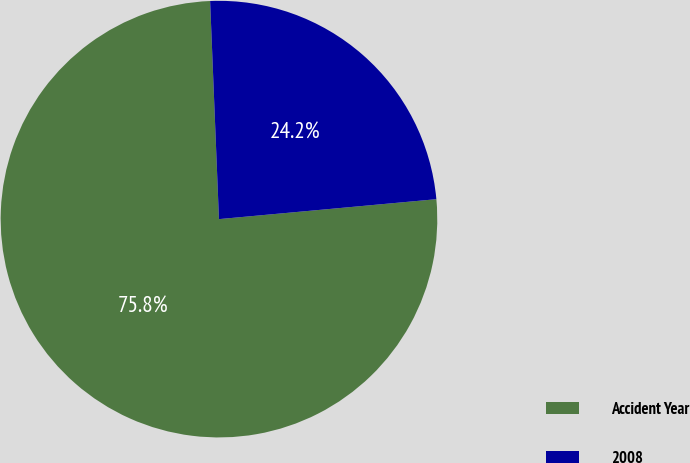Convert chart to OTSL. <chart><loc_0><loc_0><loc_500><loc_500><pie_chart><fcel>Accident Year<fcel>2008<nl><fcel>75.81%<fcel>24.19%<nl></chart> 